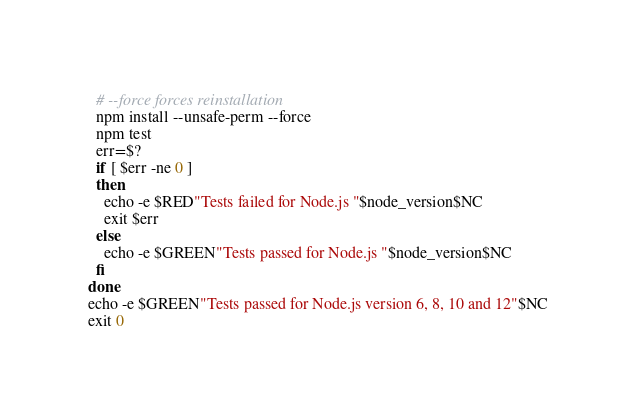Convert code to text. <code><loc_0><loc_0><loc_500><loc_500><_Bash_>  # --force forces reinstallation
  npm install --unsafe-perm --force
  npm test
  err=$?
  if [ $err -ne 0 ] 
  then
    echo -e $RED"Tests failed for Node.js "$node_version$NC
    exit $err
  else
    echo -e $GREEN"Tests passed for Node.js "$node_version$NC
  fi
done
echo -e $GREEN"Tests passed for Node.js version 6, 8, 10 and 12"$NC
exit 0</code> 